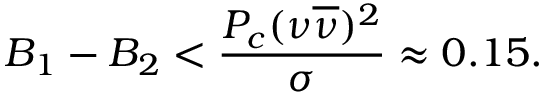<formula> <loc_0><loc_0><loc_500><loc_500>B _ { 1 } - B _ { 2 } < \frac { P _ { c } ( \nu \overline { \nu } ) ^ { 2 } } { \sigma } \approx 0 . 1 5 .</formula> 